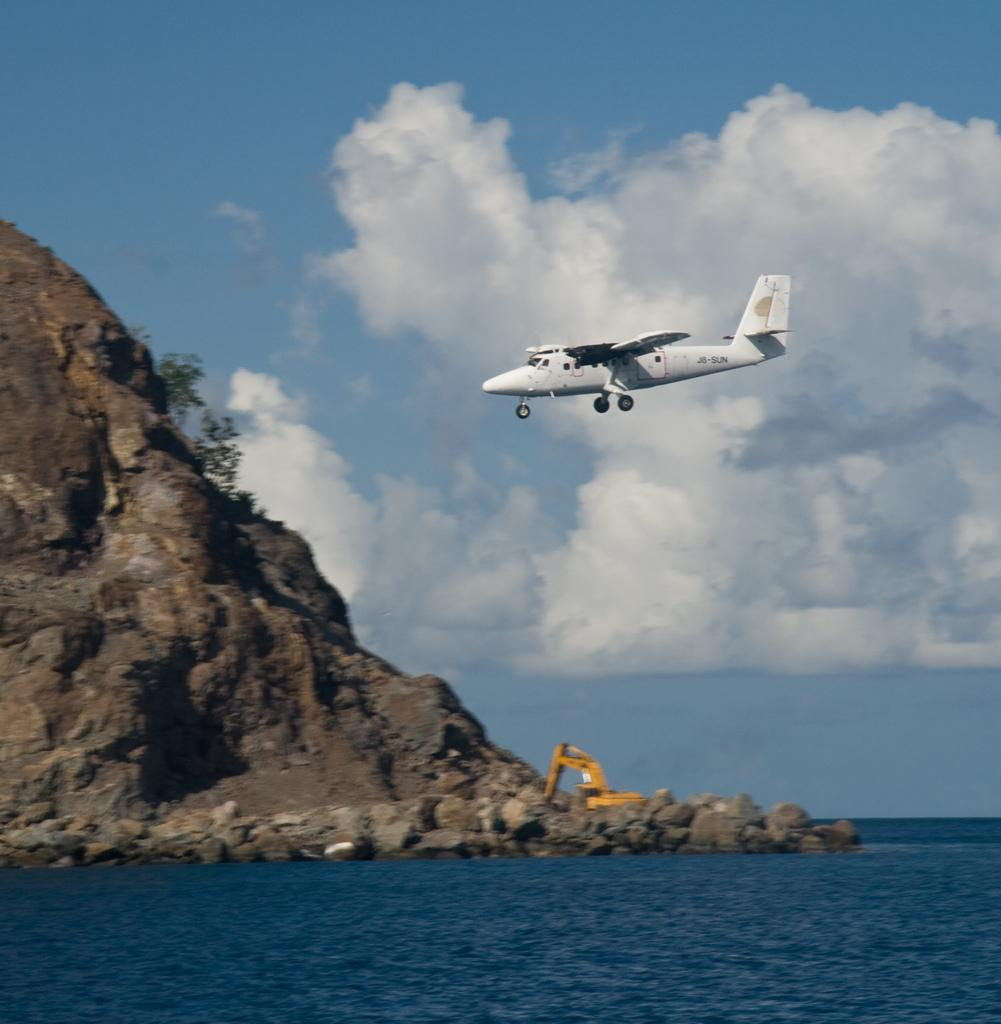What is happening in the sky in the image? There is an airplane flying in the sky in the image. How would you describe the sky's appearance? The sky appears cloudy. What type of construction equipment can be seen in the image? There is a backhoe in the image. What type of natural landscape is visible in the image? There are plants on a hill in the image. What type of large body of water is present in the image? There is a large water body in the image. What type of natural material is visible in the image? There are stones visible in the image. Where is the market located in the image? There is no market present in the image. Are there any slaves depicted in the image? There is no reference to slavery or slaves in the image. 